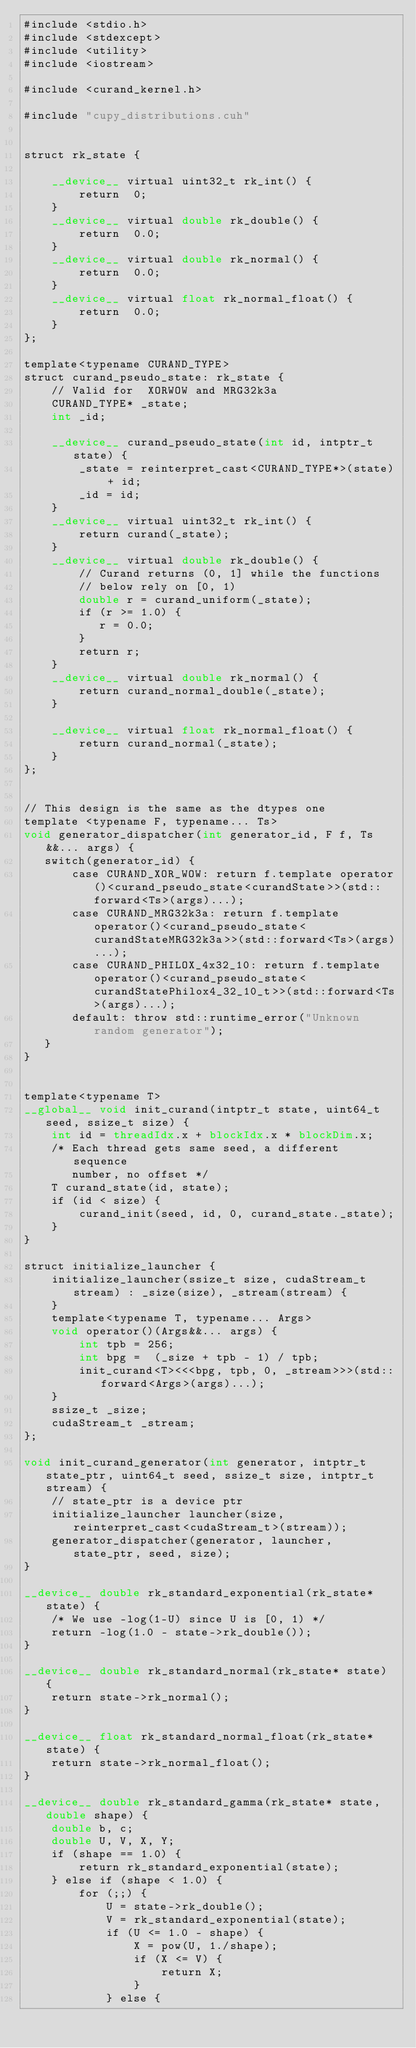Convert code to text. <code><loc_0><loc_0><loc_500><loc_500><_Cuda_>#include <stdio.h>
#include <stdexcept>
#include <utility>
#include <iostream>

#include <curand_kernel.h>

#include "cupy_distributions.cuh"


struct rk_state {

    __device__ virtual uint32_t rk_int() {
        return  0;
    }
    __device__ virtual double rk_double() {
        return  0.0;
    }
    __device__ virtual double rk_normal() {
        return  0.0;
    }
    __device__ virtual float rk_normal_float() {
        return  0.0;
    }
};

template<typename CURAND_TYPE>
struct curand_pseudo_state: rk_state {
    // Valid for  XORWOW and MRG32k3a
    CURAND_TYPE* _state;
    int _id;

    __device__ curand_pseudo_state(int id, intptr_t state) {
        _state = reinterpret_cast<CURAND_TYPE*>(state) + id;
        _id = id;
    }
    __device__ virtual uint32_t rk_int() {
        return curand(_state);
    }
    __device__ virtual double rk_double() {
        // Curand returns (0, 1] while the functions
        // below rely on [0, 1)
        double r = curand_uniform(_state);
        if (r >= 1.0) { 
           r = 0.0;
        }
        return r;
    }
    __device__ virtual double rk_normal() {
        return curand_normal_double(_state);
    }

    __device__ virtual float rk_normal_float() {
        return curand_normal(_state);
    }
};


// This design is the same as the dtypes one
template <typename F, typename... Ts>
void generator_dispatcher(int generator_id, F f, Ts&&... args) {
   switch(generator_id) {
       case CURAND_XOR_WOW: return f.template operator()<curand_pseudo_state<curandState>>(std::forward<Ts>(args)...);
       case CURAND_MRG32k3a: return f.template operator()<curand_pseudo_state<curandStateMRG32k3a>>(std::forward<Ts>(args)...);
       case CURAND_PHILOX_4x32_10: return f.template operator()<curand_pseudo_state<curandStatePhilox4_32_10_t>>(std::forward<Ts>(args)...);
       default: throw std::runtime_error("Unknown random generator");
   }
}


template<typename T>
__global__ void init_curand(intptr_t state, uint64_t seed, ssize_t size) {
    int id = threadIdx.x + blockIdx.x * blockDim.x;
    /* Each thread gets same seed, a different sequence
       number, no offset */
    T curand_state(id, state);
    if (id < size) {
        curand_init(seed, id, 0, curand_state._state);    
    }
}

struct initialize_launcher {
    initialize_launcher(ssize_t size, cudaStream_t stream) : _size(size), _stream(stream) {
    }
    template<typename T, typename... Args>
    void operator()(Args&&... args) { 
        int tpb = 256;
        int bpg =  (_size + tpb - 1) / tpb;
        init_curand<T><<<bpg, tpb, 0, _stream>>>(std::forward<Args>(args)...);
    }
    ssize_t _size;
    cudaStream_t _stream;
};

void init_curand_generator(int generator, intptr_t state_ptr, uint64_t seed, ssize_t size, intptr_t stream) {
    // state_ptr is a device ptr
    initialize_launcher launcher(size, reinterpret_cast<cudaStream_t>(stream));
    generator_dispatcher(generator, launcher, state_ptr, seed, size);
}

__device__ double rk_standard_exponential(rk_state* state) {
    /* We use -log(1-U) since U is [0, 1) */
    return -log(1.0 - state->rk_double());
}

__device__ double rk_standard_normal(rk_state* state) {
    return state->rk_normal();
}

__device__ float rk_standard_normal_float(rk_state* state) {
    return state->rk_normal_float();
}

__device__ double rk_standard_gamma(rk_state* state, double shape) {
    double b, c;
    double U, V, X, Y;
    if (shape == 1.0) {
        return rk_standard_exponential(state);
    } else if (shape < 1.0) {
        for (;;) {
            U = state->rk_double();
            V = rk_standard_exponential(state);
            if (U <= 1.0 - shape) {
                X = pow(U, 1./shape);
                if (X <= V) {
                    return X;
                }
            } else {</code> 